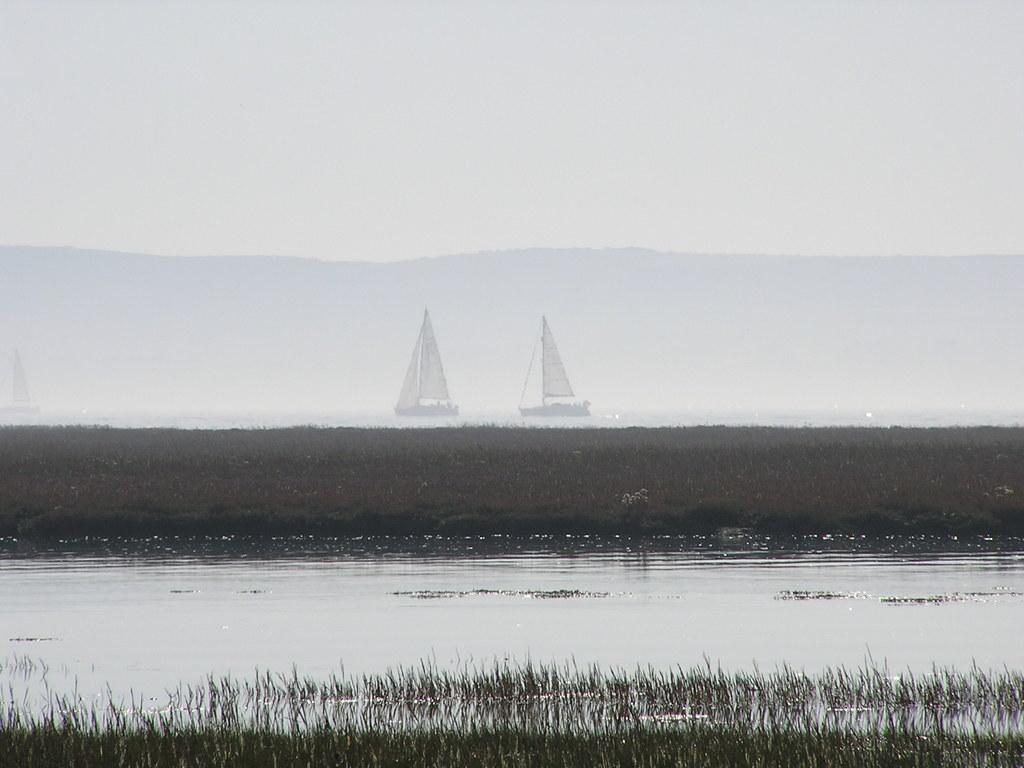What can be seen in the image? There are ships and water visible in the image. What is the water covering? Some part of the water is covered with grass. What type of calculator is floating on the water in the image? There is no calculator present in the image; it features ships and water covered with grass. 